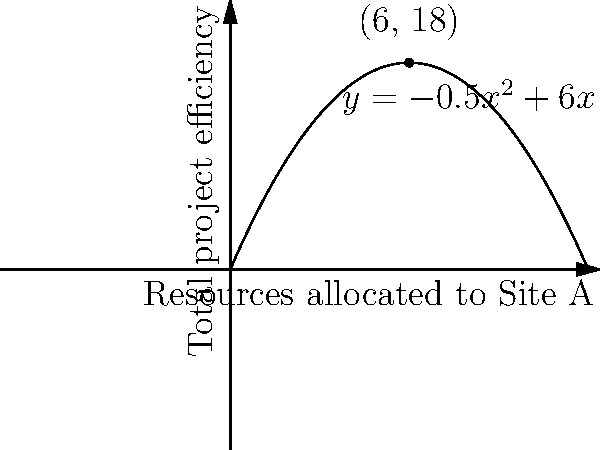Amentum is managing a project across two sites, A and B. The total project efficiency (E) in relation to resources (x) allocated to Site A is modeled by the quadratic function $E = -0.5x^2 + 6x$, where x is measured in millions of dollars. What is the optimal resource allocation to Site A that maximizes the total project efficiency, and what is this maximum efficiency? To find the optimal resource allocation and maximum efficiency, we'll follow these steps:

1) The function for total project efficiency is $E = -0.5x^2 + 6x$

2) To find the maximum point, we need to find where the derivative of this function equals zero:
   $\frac{dE}{dx} = -x + 6$
   
3) Set this equal to zero and solve:
   $-x + 6 = 0$
   $x = 6$

4) This critical point (x = 6) gives us the optimal resource allocation to Site A: 6 million dollars.

5) To find the maximum efficiency, we plug x = 6 back into our original function:
   $E = -0.5(6)^2 + 6(6)$
   $E = -0.5(36) + 36$
   $E = -18 + 36 = 18$

6) Therefore, the maximum efficiency is 18 units.

7) We can verify this is a maximum (not a minimum) because the coefficient of $x^2$ is negative, making the parabola open downwards.

This result is visually confirmed by the vertex of the parabola in the graph at the point (6, 18).
Answer: Optimal allocation: $6 million to Site A; Maximum efficiency: 18 units 